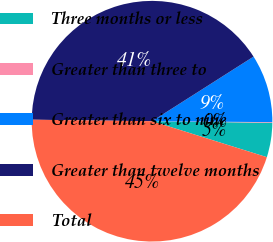Convert chart. <chart><loc_0><loc_0><loc_500><loc_500><pie_chart><fcel>Three months or less<fcel>Greater than three to<fcel>Greater than six to nine<fcel>Greater than twelve months<fcel>Total<nl><fcel>4.62%<fcel>0.09%<fcel>9.14%<fcel>40.78%<fcel>45.37%<nl></chart> 